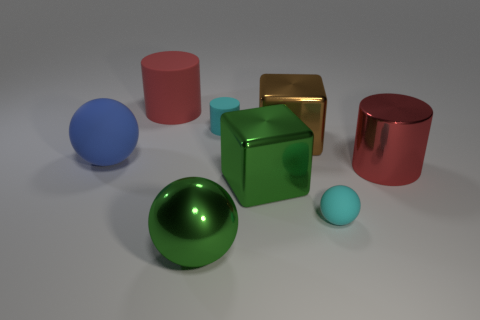What materials do the objects appear to be made of? The materials that the objects seem to be made of vary; the spheres and cylinders have a matte finish suggesting a clay or plastic composition, while the cube in the center has a reflective surface that could indicate a metallic material, possibly gold or brass.  Considering their appearance, what could these objects be used for? Considering their simplistic geometrical shapes and the varied materials, these objects might be used as visual aids for educational purposes, such as teaching geometry or showcasing the properties of light on different surfaces. 